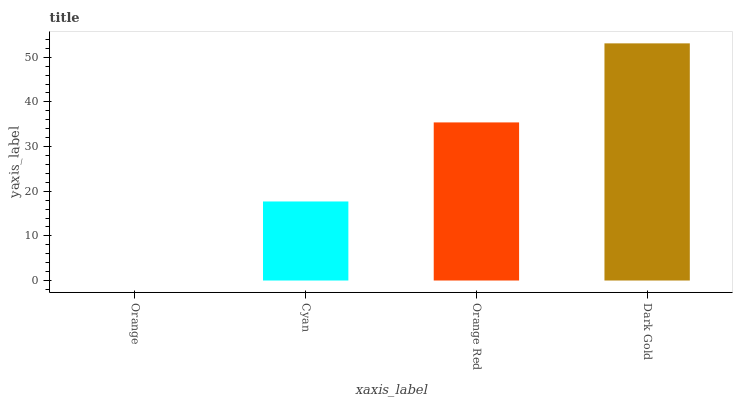Is Orange the minimum?
Answer yes or no. Yes. Is Dark Gold the maximum?
Answer yes or no. Yes. Is Cyan the minimum?
Answer yes or no. No. Is Cyan the maximum?
Answer yes or no. No. Is Cyan greater than Orange?
Answer yes or no. Yes. Is Orange less than Cyan?
Answer yes or no. Yes. Is Orange greater than Cyan?
Answer yes or no. No. Is Cyan less than Orange?
Answer yes or no. No. Is Orange Red the high median?
Answer yes or no. Yes. Is Cyan the low median?
Answer yes or no. Yes. Is Dark Gold the high median?
Answer yes or no. No. Is Dark Gold the low median?
Answer yes or no. No. 